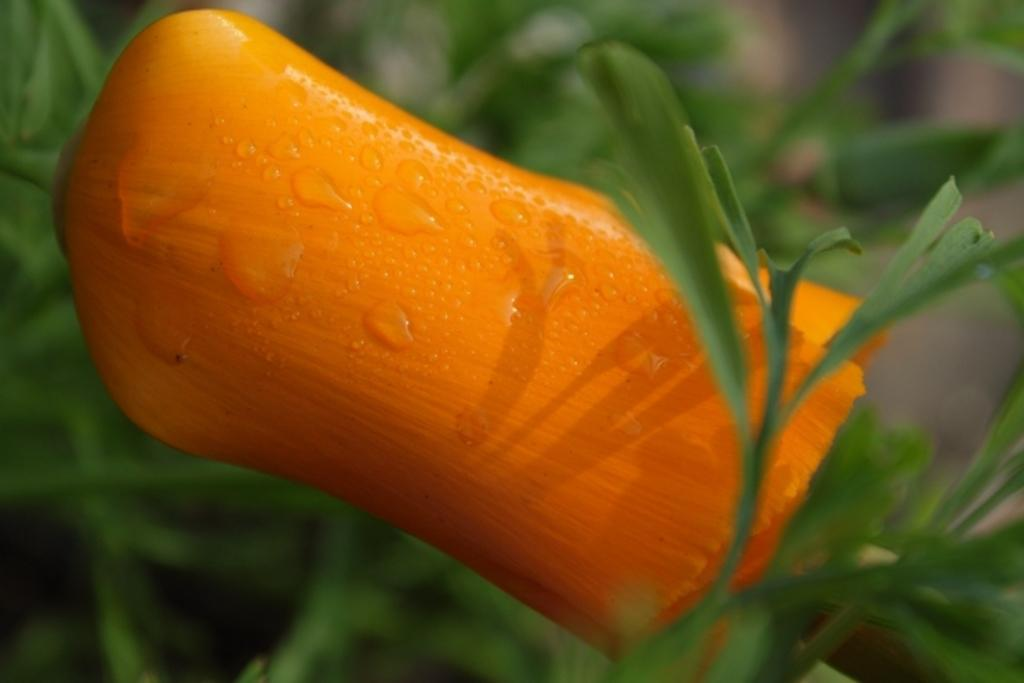What is the main subject of the image? There is a flower in the image. What else can be seen around the flower? There are leaves surrounding the flower in the image. What type of business is being conducted in the image? There is no indication of any business being conducted in the image; it features a flower surrounded by leaves. Is there a man present in the image? There is no man present in the image; it features a flower surrounded by leaves. 